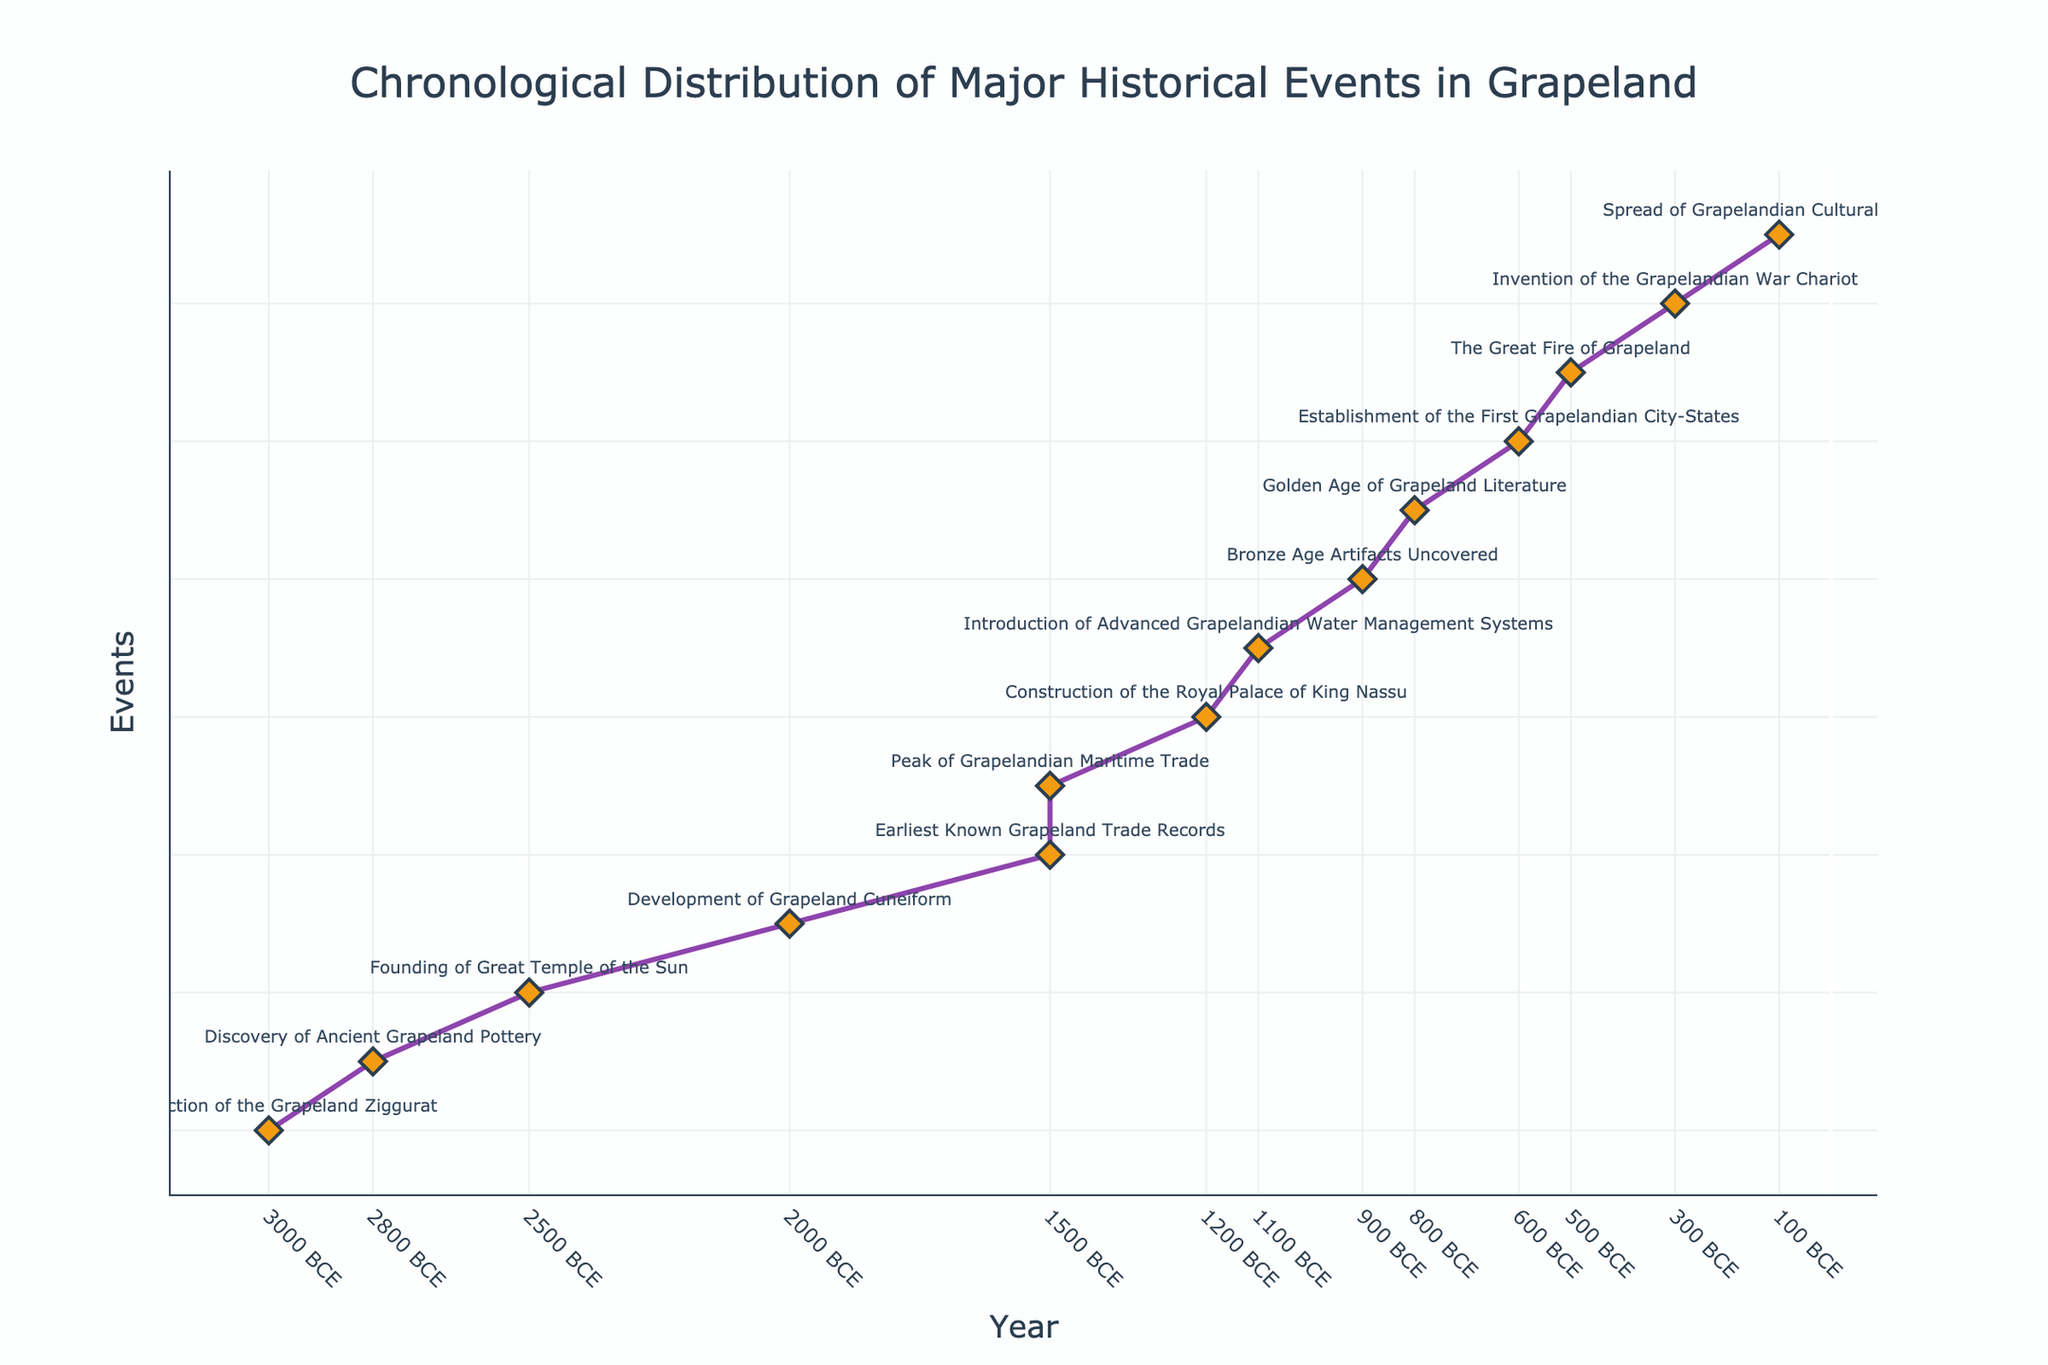What's the title of the figure? The title of the figure is located at the top and summarizes the content of the plot.
Answer: Chronological Distribution of Major Historical Events in Grapeland How many data points (events) are displayed in the figure? Count the markers (diamond symbols) on the plot to determine the number of data points.
Answer: 14 Which event occurred closest to 1000 BCE? Identify the events plotted around 1000 BCE and determine the one nearest to this year.
Answer: Bronze Age Artifacts Uncovered What is the range of years covered in the figure? The range is calculated by identifying the earliest and latest years on the x-axis. The earliest year is 3000 BCE and the latest is 1500 CE.
Answer: 4500 years How many events occurred before 1000 BCE? Count the markers on the plot occurring before the year 1000 BCE.
Answer: 7 Which event had the most recent significance in the dataset? Look for the event with the latest year on the x-axis and refer to its description.
Answer: Peak of Grapelandian Maritime Trade What is the average time gap between the events? Determine the time intervals between successive events, sum these intervals, and then divide by the number of gaps (total events minus one).
Answer: 346 years Which two events are closest to each other in time? Calculate the time gaps between each pair of successive events and identify the smallest gap.
Answer: The Great Fire of Grapeland and Golden Age of Grapeland Literature How did the establishment of the First Grapelandian City-States compare in date to the construction of the Royal Palace of King Nassu? Look for the years corresponding to these two events on the x-axis and compare them. The Royal Palace of King Nassu was constructed in 1200 BCE, while the City-States were established in 600 BCE.
Answer: The City-States were established 600 years after the Royal Palace Which period had the highest concentration of events? Identify periods on the plot with the most markers clustered together within a short time span.
Answer: The period around 1000-1500 CE has the highest concentration of events 